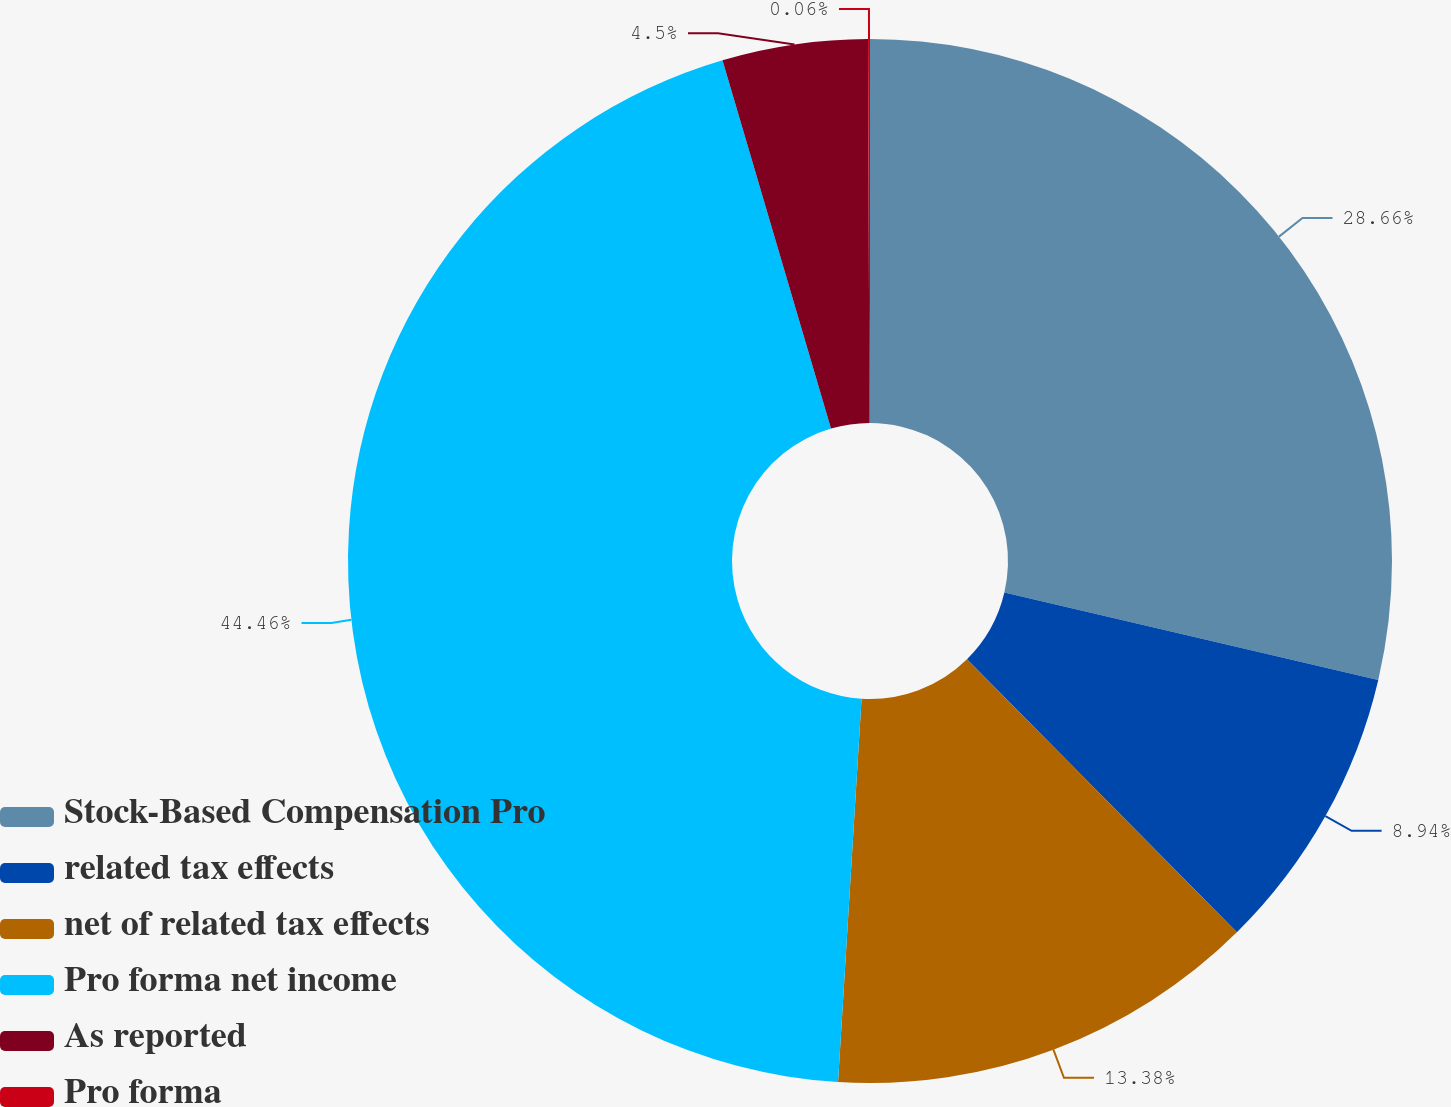Convert chart. <chart><loc_0><loc_0><loc_500><loc_500><pie_chart><fcel>Stock-Based Compensation Pro<fcel>related tax effects<fcel>net of related tax effects<fcel>Pro forma net income<fcel>As reported<fcel>Pro forma<nl><fcel>28.66%<fcel>8.94%<fcel>13.38%<fcel>44.47%<fcel>4.5%<fcel>0.06%<nl></chart> 